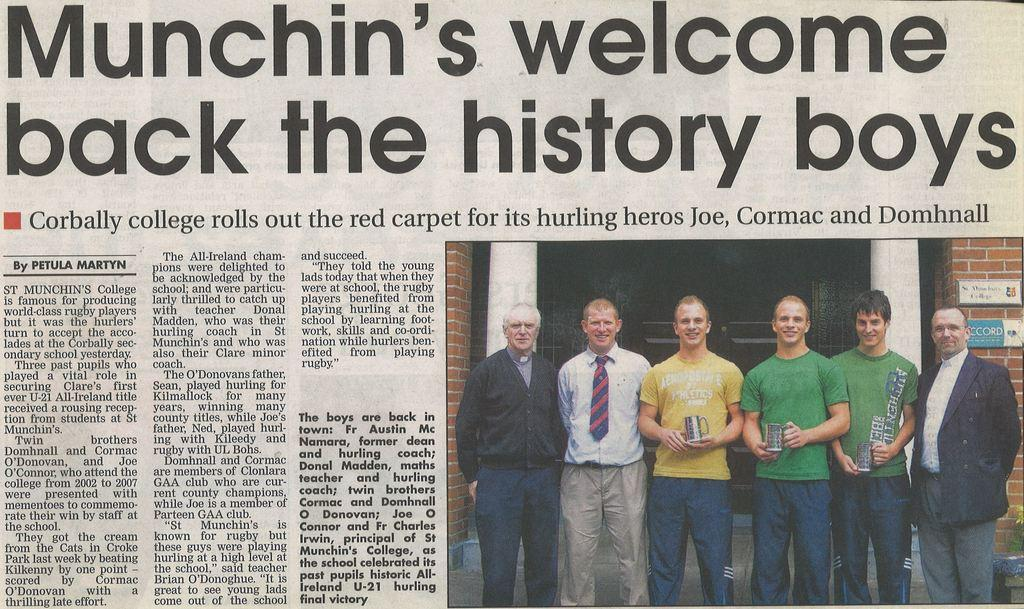What is the main subject of the image? The main subject of the image is a picture of a newspaper. What can be seen in the picture within the image? There are people standing in the picture of the newspaper. What type of button is being discussed in the newspaper article? There is no mention of a button in the image or the newspaper article, as the image only shows a picture of a newspaper with people standing in it. 